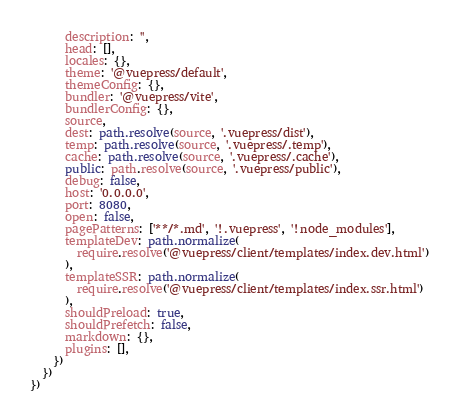<code> <loc_0><loc_0><loc_500><loc_500><_TypeScript_>      description: '',
      head: [],
      locales: {},
      theme: '@vuepress/default',
      themeConfig: {},
      bundler: '@vuepress/vite',
      bundlerConfig: {},
      source,
      dest: path.resolve(source, '.vuepress/dist'),
      temp: path.resolve(source, '.vuepress/.temp'),
      cache: path.resolve(source, '.vuepress/.cache'),
      public: path.resolve(source, '.vuepress/public'),
      debug: false,
      host: '0.0.0.0',
      port: 8080,
      open: false,
      pagePatterns: ['**/*.md', '!.vuepress', '!node_modules'],
      templateDev: path.normalize(
        require.resolve('@vuepress/client/templates/index.dev.html')
      ),
      templateSSR: path.normalize(
        require.resolve('@vuepress/client/templates/index.ssr.html')
      ),
      shouldPreload: true,
      shouldPrefetch: false,
      markdown: {},
      plugins: [],
    })
  })
})
</code> 